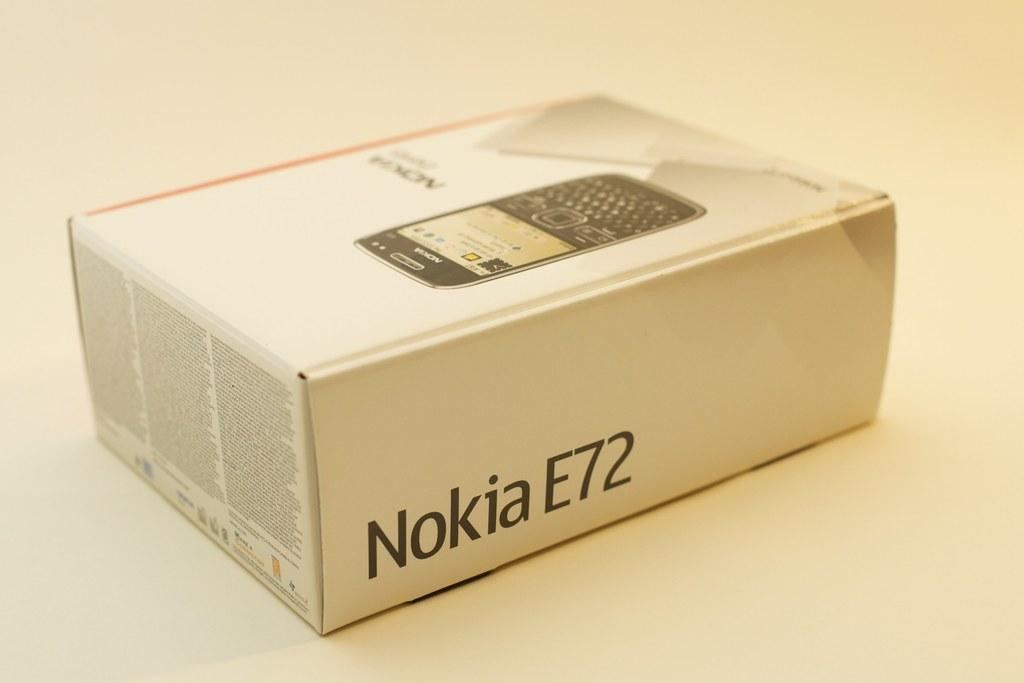<image>
Summarize the visual content of the image. A box for a Nokia E72 phone on a white table. 